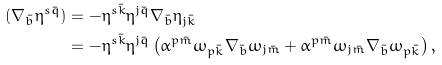Convert formula to latex. <formula><loc_0><loc_0><loc_500><loc_500>( \nabla _ { \bar { b } } \eta ^ { s \bar { q } } ) & = - \eta ^ { s \bar { k } } \eta ^ { j \bar { q } } \nabla _ { \bar { b } } \eta _ { j \bar { k } } \\ & = - \eta ^ { s \bar { k } } \eta ^ { j \bar { q } } \left ( \alpha ^ { p \bar { m } } \omega _ { p \bar { k } } \nabla _ { \bar { b } } \omega _ { j \bar { m } } + \alpha ^ { p \bar { m } } \omega _ { j \bar { m } } \nabla _ { \bar { b } } \omega _ { p \bar { k } } \right ) ,</formula> 